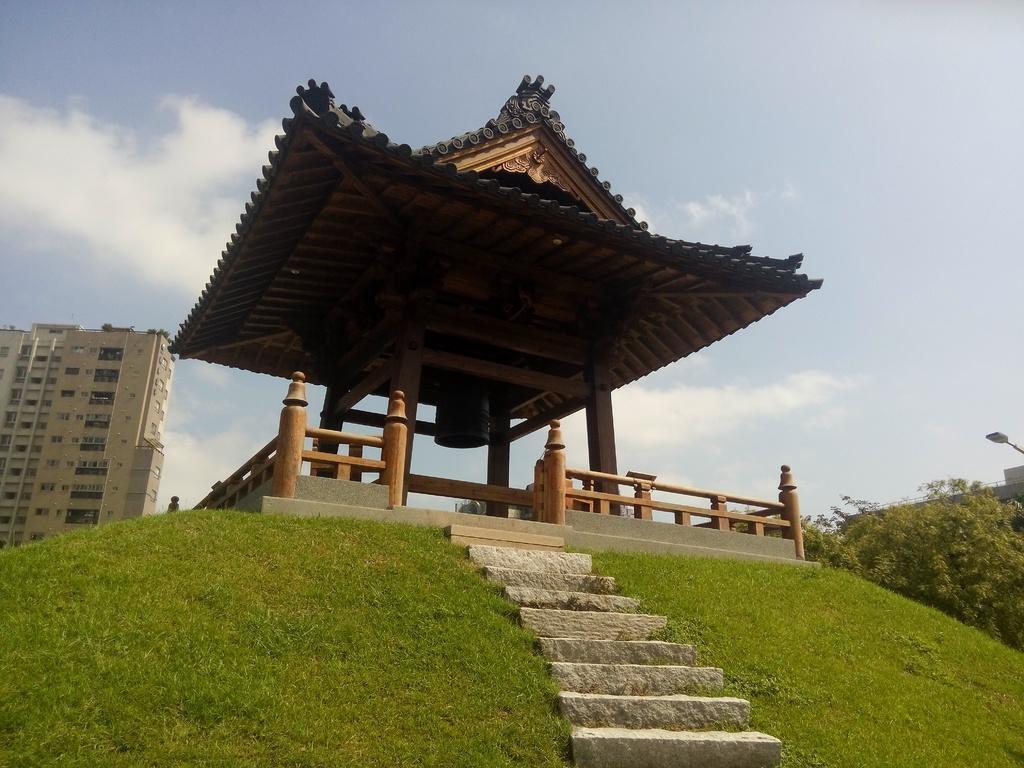Please provide a concise description of this image. In this image there is a shrine with steps in front of that on a grass, behind that there are so many plants and building. 